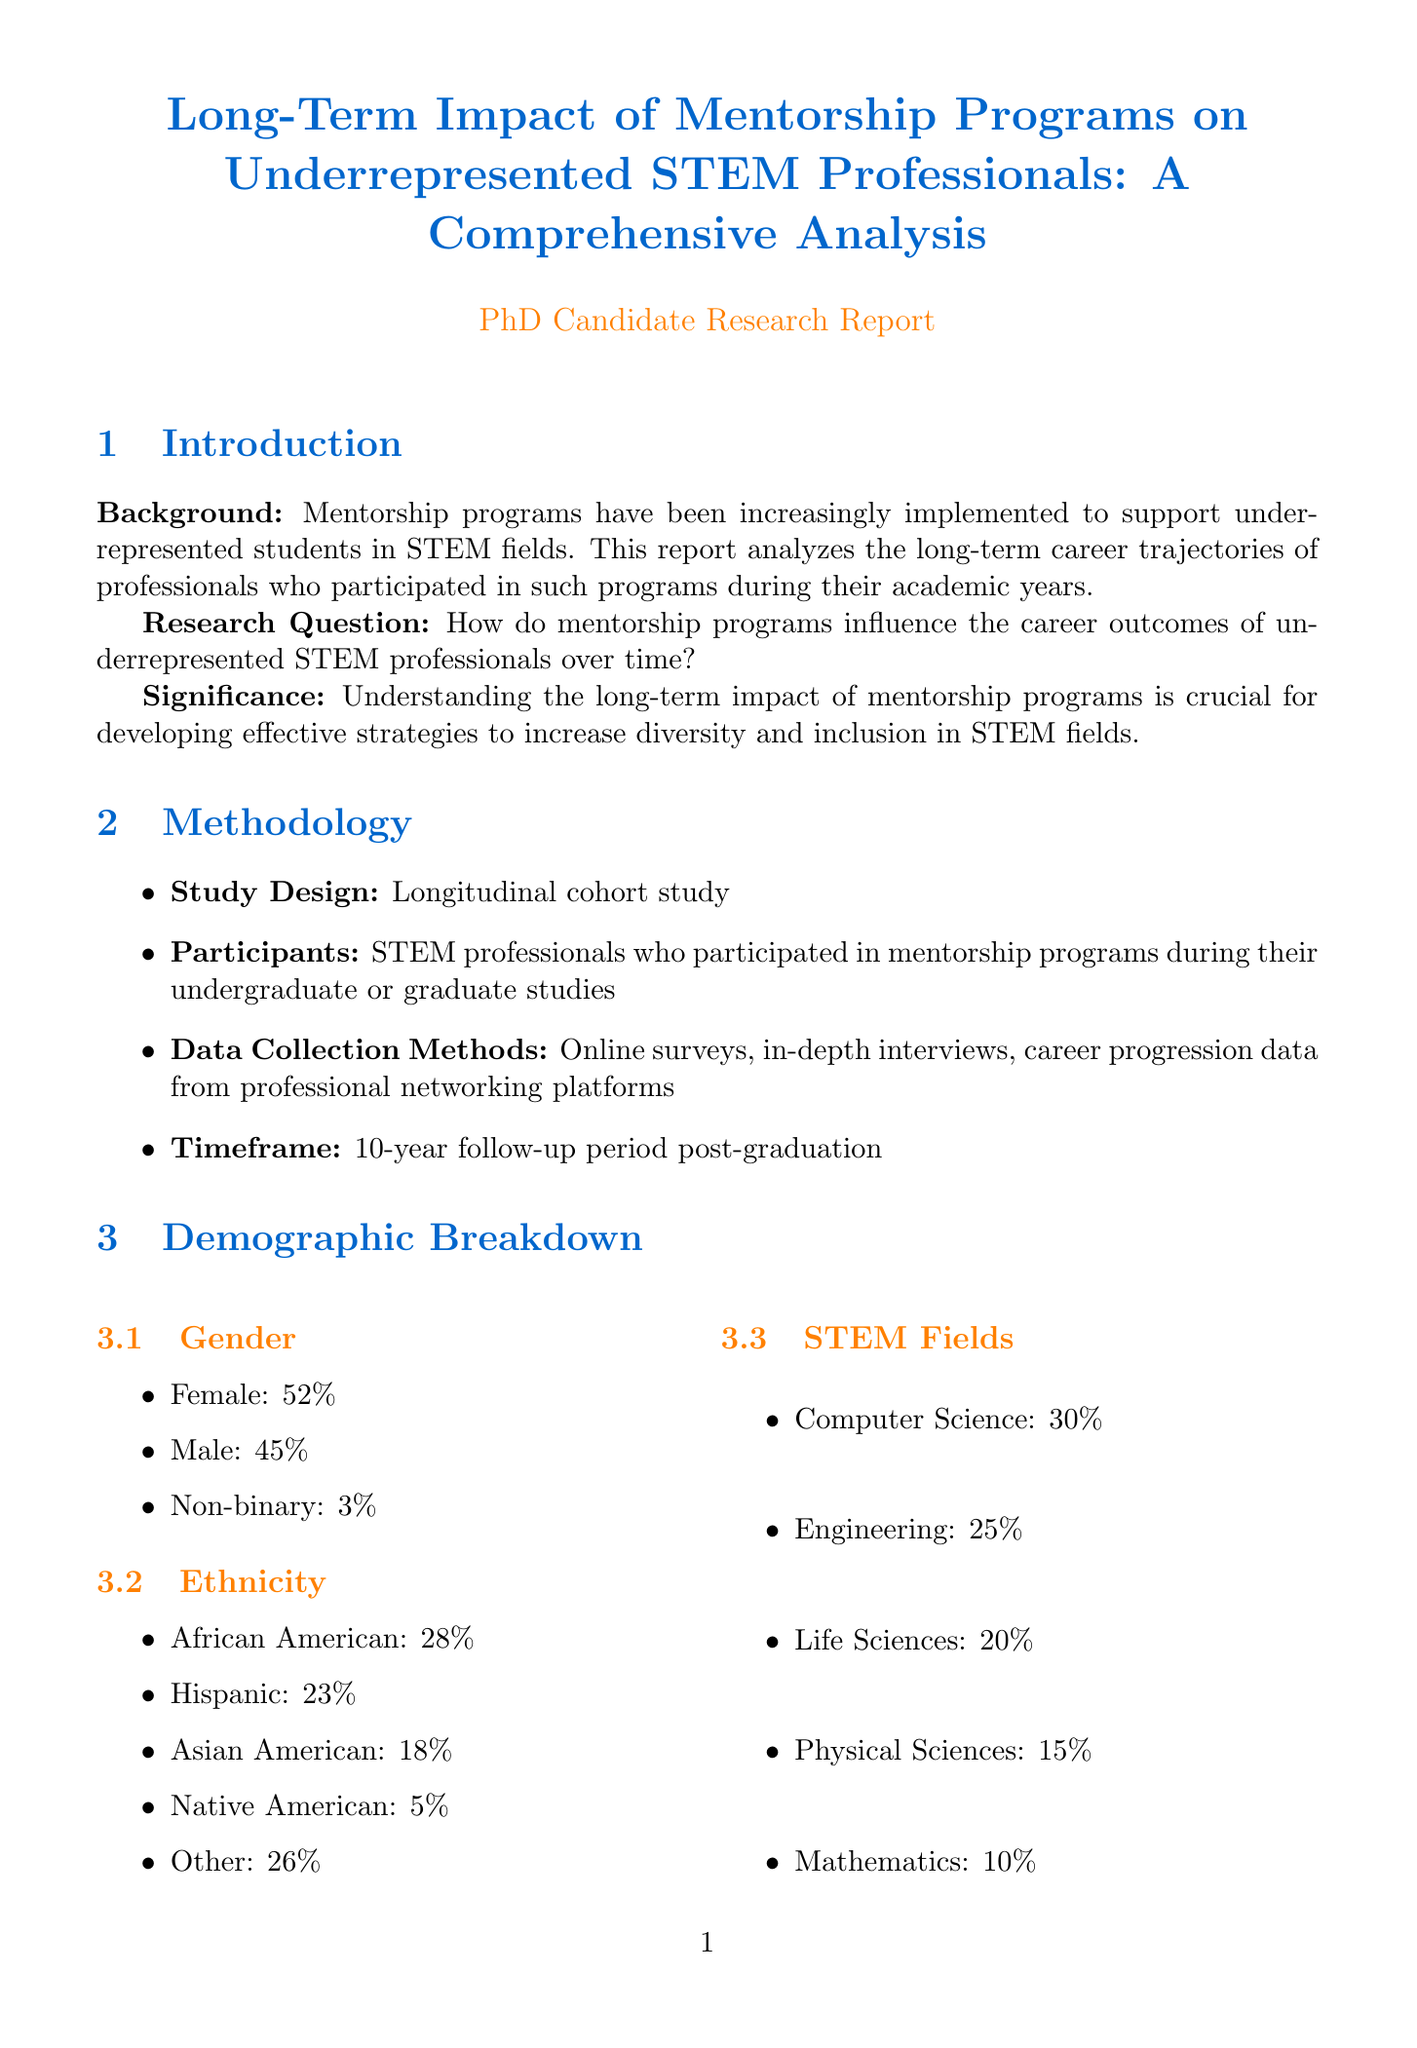What is the title of the report? The title is stated at the beginning of the document, summarizing the focus of the analysis.
Answer: Long-Term Impact of Mentorship Programs on Underrepresented STEM Professionals: A Comprehensive Analysis What was the study design used in the methodology? The methodology section specifies the type of study conducted to analyze the data collected.
Answer: Longitudinal cohort study What percentage of participants were female? The demographic breakdown section provides specific statistics about the gender distribution of participants.
Answer: 52% What was the average annual salary increase reported? This figure is included in the success metrics section detailing salary growth outcomes.
Answer: 7.5% What is one of the key findings regarding career retention? The key findings indicate retention rates compared to non-mentored peers, reflecting the impact of mentorship.
Answer: 85% How many publications and patents did mentored professionals average? This information is provided in the success metrics section related to academic productivity.
Answer: 12.3 What recommendation discusses mentor training? The recommendations outline specific strategies to improve mentorship quality, including mentorship provider preparation.
Answer: Develop mentor training programs What is the time frame for the follow-up period post-graduation? The methodology section outlines the duration of the follow-up study for participants.
Answer: 10-year follow-up period post-graduation What specific challenge involves mentor-mentee relationships? The challenges section highlights issues related to the ongoing dynamics of mentorship engagements.
Answer: Maintaining long-term engagement between mentors and mentees 